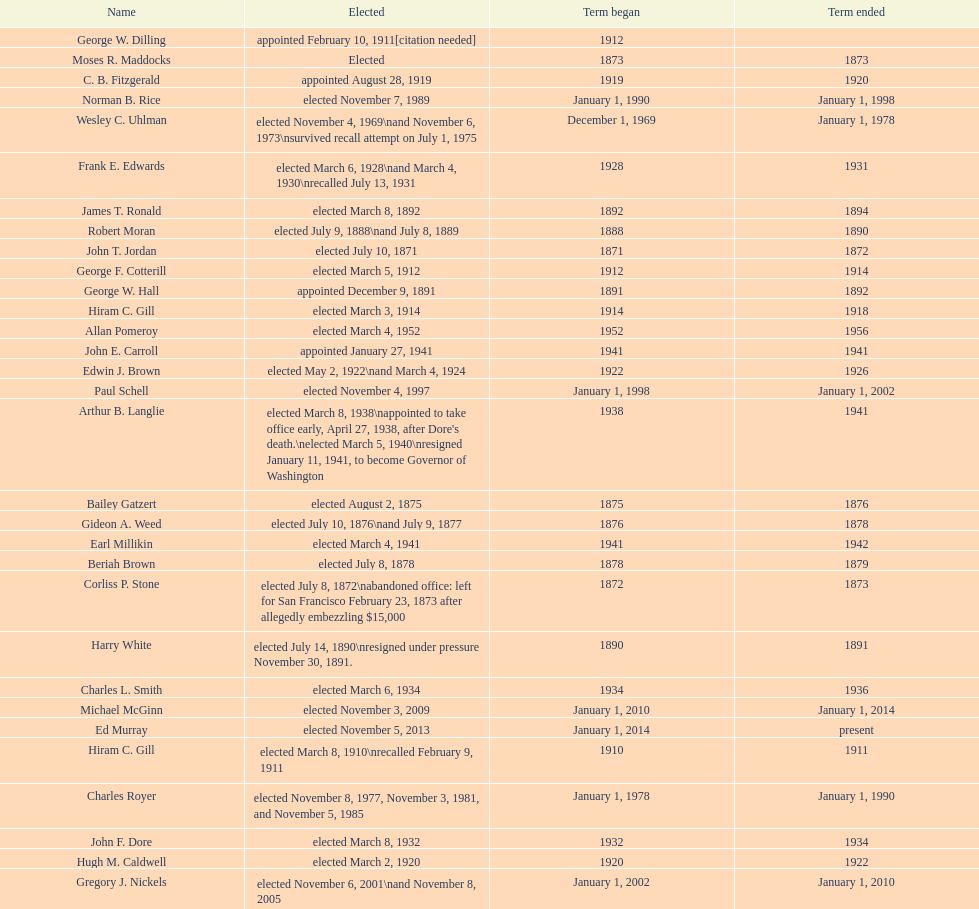Who was the mayor before jordan? Henry A. Atkins. 